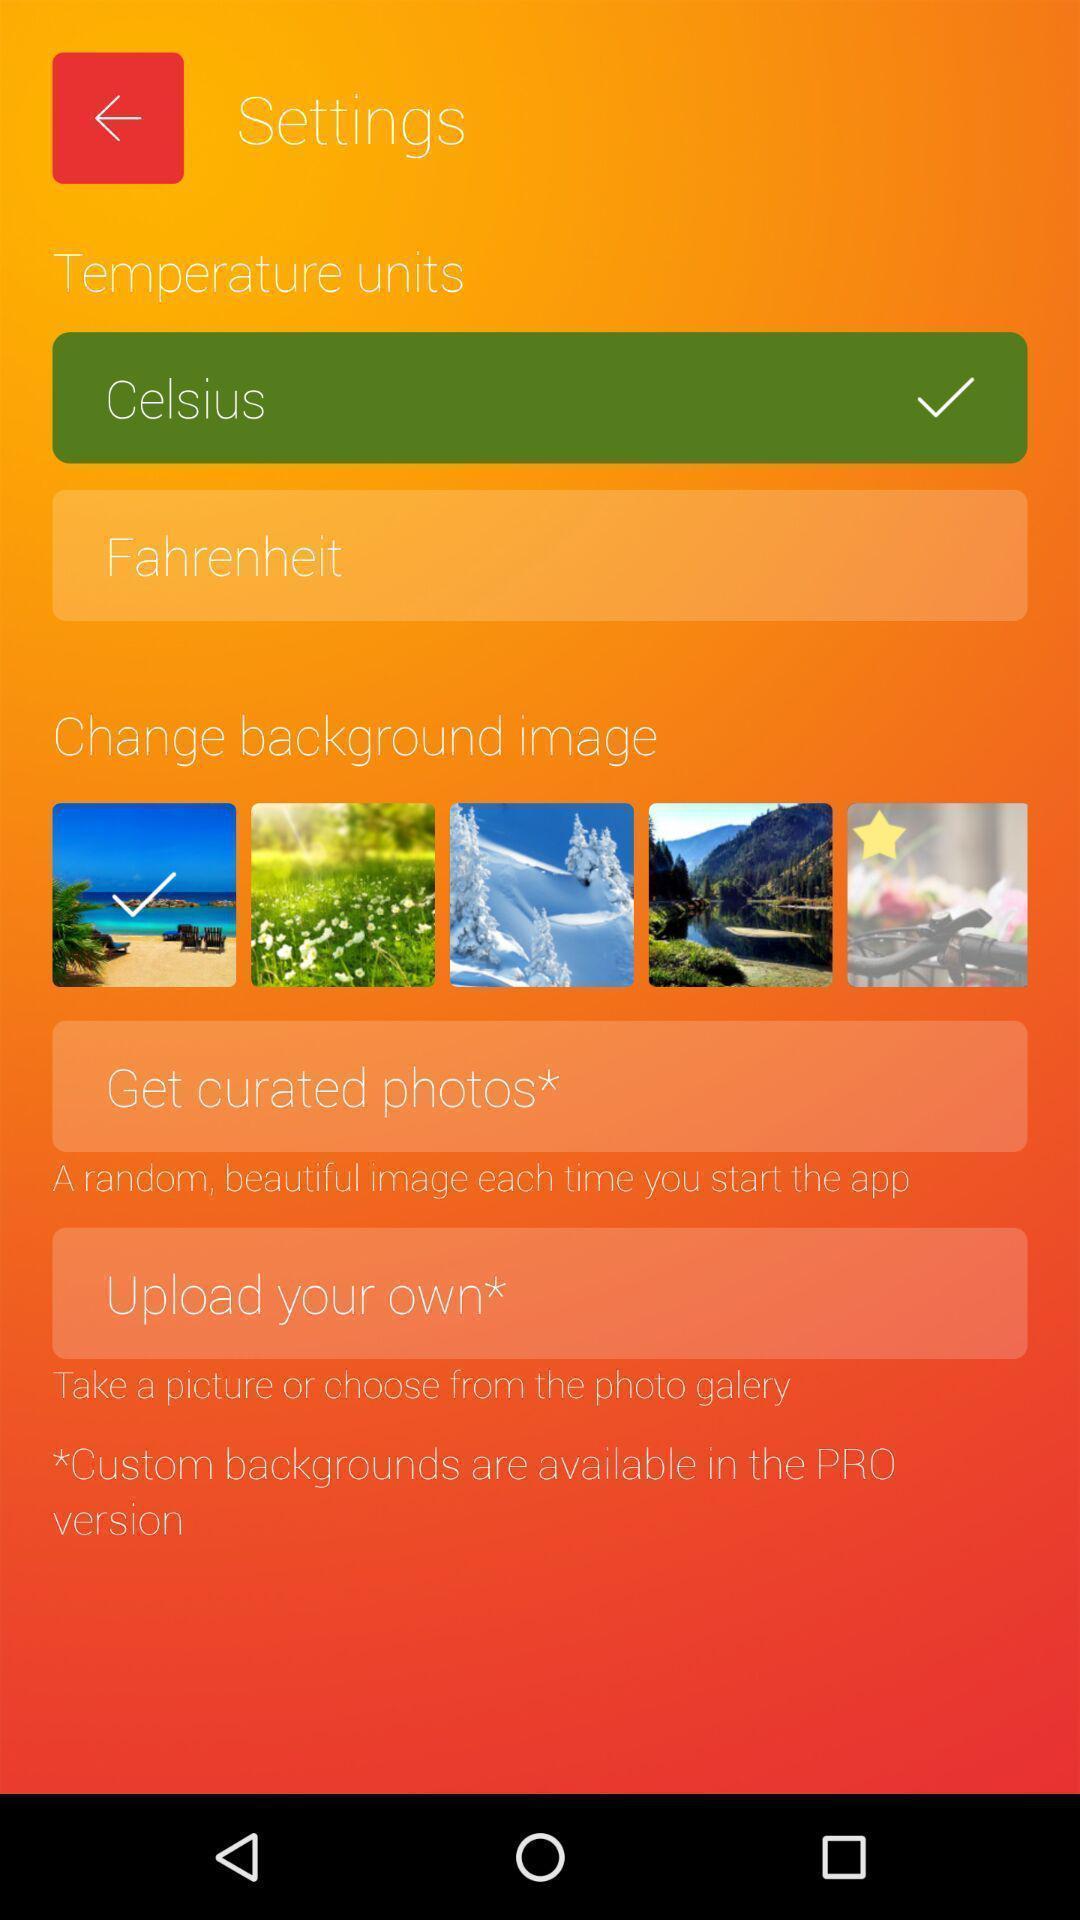Provide a description of this screenshot. Screen displaying multiple temperature setting options. 